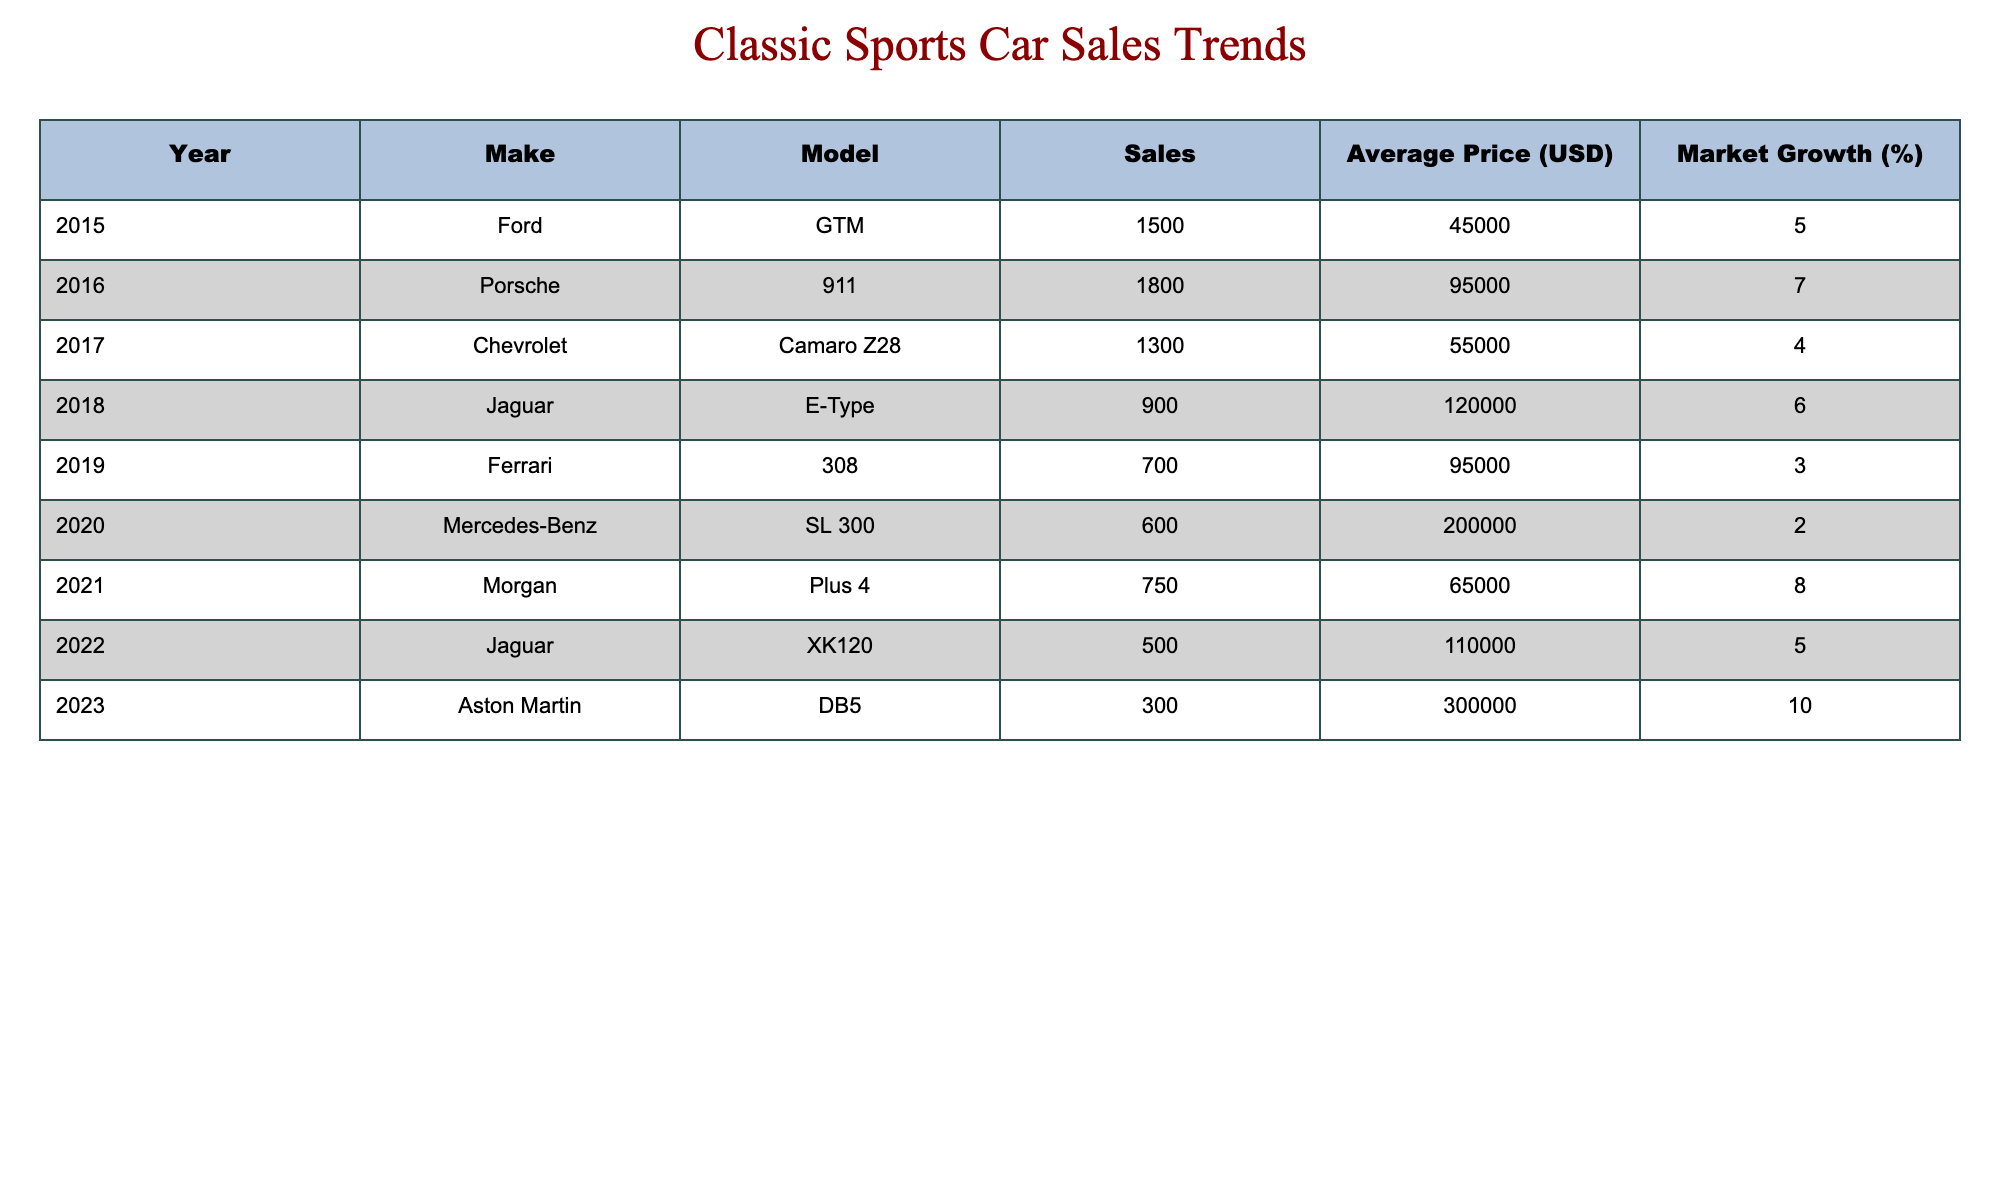What was the highest average price among the classic sports cars sold? The table shows the average prices for each car sold in different years. The highest average price is listed for the Aston Martin DB5 in 2023, with an average price of 300,000 USD.
Answer: 300000 Which car had the lowest sales in 2022? The table presents the sales figures for each car by year. In 2022, the Jaguar XK120 had the lowest sales, with only 500 units sold.
Answer: 500 What is the total sales of all cars from 2015 to 2021? To find the total sales from 2015 to 2021, we add the sales figures for each year: 1500 + 1800 + 1300 + 900 + 600 + 750 = 5050.
Answer: 5050 Did the sales of the Porsche 911 exceed the sales of the Chevrolet Camaro Z28? The sales for the Porsche 911 in 2016 were 1800 units, while the sales for the Chevrolet Camaro Z28 in 2017 were 1300 units. Therefore, the sales of the Porsche 911 did exceed those of the Camaro Z28.
Answer: Yes How much did the average price of cars increase from 2015 to 2022? We compare the average prices from the years 2015 (45,000 USD) and 2022 (110,000 USD). The increase is calculated as 110,000 - 45,000 = 65,000 USD.
Answer: 65000 Which car had the highest market growth, and what was that percentage? The market growth percentages are listed for each car in the table. The Aston Martin DB5 had the highest market growth at 10% in 2023.
Answer: 10% What was the average price of cars sold in 2019 and 2020? The average prices for 2019 (95,000 USD) and 2020 (200,000 USD) are added together and divided by 2 to find the average. The calculation is (95,000 + 200,000) / 2 = 147,500 USD.
Answer: 147500 How did the sales of the Jaguar E-Type in 2018 compare to the Aston Martin DB5 in 2023? The Jaguar E-Type had sales of 900 units in 2018, while the Aston Martin DB5 had sales of 300 units in 2023. Therefore, the Jaguar E-Type sold significantly more.
Answer: Jaguar E-Type sold more In which year was the market growth for Morgan Plus 4 the highest compared to other cars? The market growth for the Morgan Plus 4 in 2021 was 8%, which is the highest among all the cars listed in the table.
Answer: 8% 